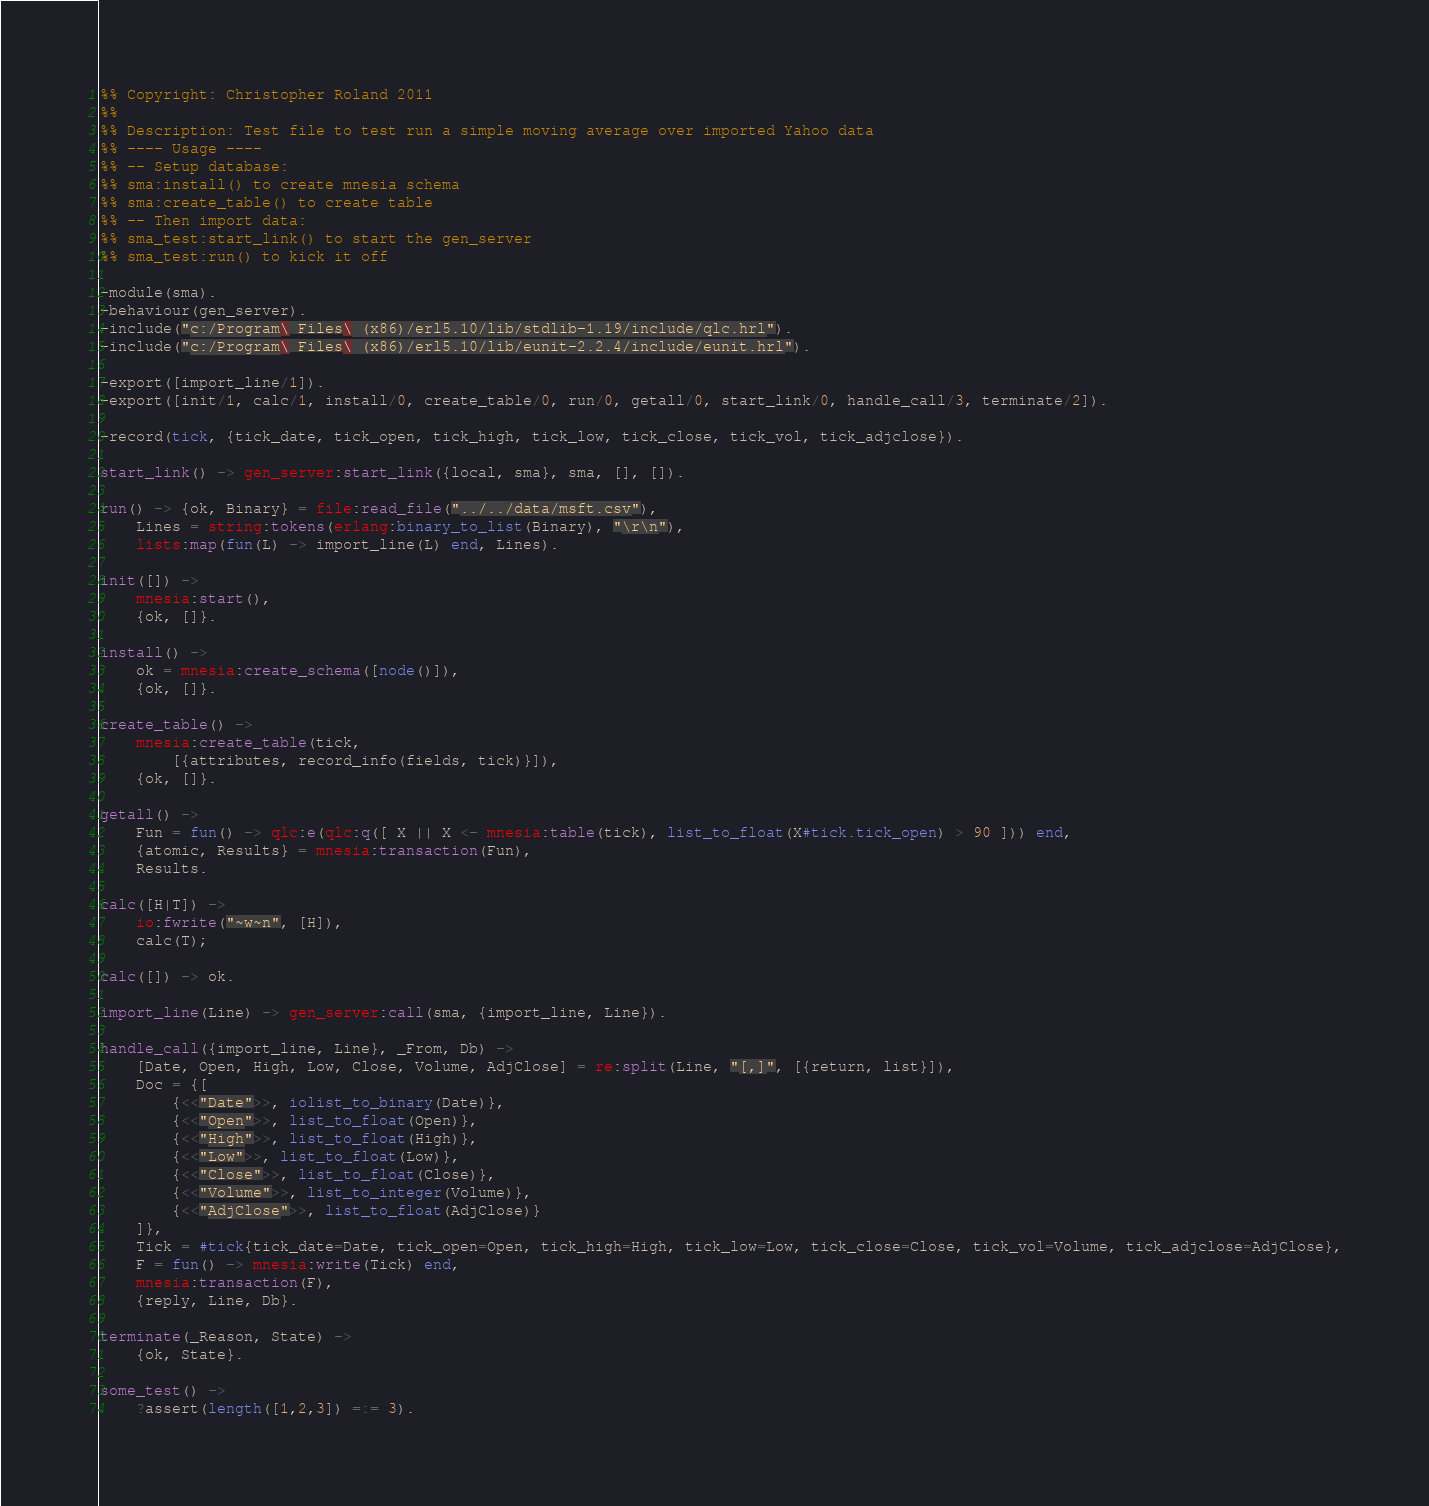Convert code to text. <code><loc_0><loc_0><loc_500><loc_500><_Erlang_>%% Copyright: Christopher Roland 2011
%% 
%% Description: Test file to test run a simple moving average over imported Yahoo data 
%% ---- Usage ----
%% -- Setup database:
%% sma:install() to create mnesia schema 
%% sma:create_table() to create table
%% -- Then import data:
%% sma_test:start_link() to start the gen_server
%% sma_test:run() to kick it off

-module(sma).
-behaviour(gen_server).
-include("c:/Program\ Files\ (x86)/erl5.10/lib/stdlib-1.19/include/qlc.hrl").
-include("c:/Program\ Files\ (x86)/erl5.10/lib/eunit-2.2.4/include/eunit.hrl").

-export([import_line/1]).
-export([init/1, calc/1, install/0, create_table/0, run/0, getall/0, start_link/0, handle_call/3, terminate/2]).

-record(tick, {tick_date, tick_open, tick_high, tick_low, tick_close, tick_vol, tick_adjclose}).

start_link() -> gen_server:start_link({local, sma}, sma, [], []).	

run() -> {ok, Binary} = file:read_file("../../data/msft.csv"),
	Lines = string:tokens(erlang:binary_to_list(Binary), "\r\n"),
	lists:map(fun(L) -> import_line(L) end, Lines).

init([]) -> 
	mnesia:start(),
	{ok, []}.

install() ->
	ok = mnesia:create_schema([node()]),
	{ok, []}.

create_table() ->
	mnesia:create_table(tick, 
		[{attributes, record_info(fields, tick)}]),
	{ok, []}.

getall() ->
	Fun = fun() -> qlc:e(qlc:q([ X || X <- mnesia:table(tick), list_to_float(X#tick.tick_open) > 90 ])) end,
	{atomic, Results} = mnesia:transaction(Fun),
	Results.

calc([H|T]) ->
	io:fwrite("~w~n", [H]),
	calc(T);

calc([]) -> ok.

import_line(Line) -> gen_server:call(sma, {import_line, Line}).	

handle_call({import_line, Line}, _From, Db) ->
	[Date, Open, High, Low, Close, Volume, AdjClose] = re:split(Line, "[,]", [{return, list}]),
	Doc = {[
		{<<"Date">>, iolist_to_binary(Date)}, 
		{<<"Open">>, list_to_float(Open)},
		{<<"High">>, list_to_float(High)},
		{<<"Low">>, list_to_float(Low)},
		{<<"Close">>, list_to_float(Close)},
		{<<"Volume">>, list_to_integer(Volume)},
		{<<"AdjClose">>, list_to_float(AdjClose)}
	]},
	Tick = #tick{tick_date=Date, tick_open=Open, tick_high=High, tick_low=Low, tick_close=Close, tick_vol=Volume, tick_adjclose=AdjClose},
	F = fun() -> mnesia:write(Tick) end,
	mnesia:transaction(F),
	{reply, Line, Db}.

terminate(_Reason, State) -> 
	{ok, State}.

some_test() ->
	?assert(length([1,2,3]) =:= 3).
</code> 